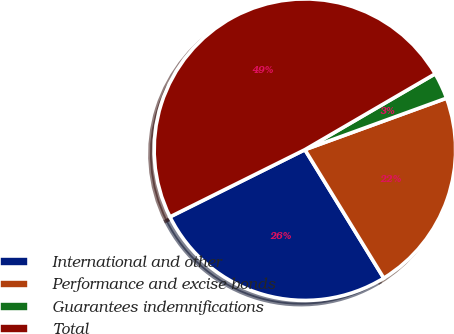<chart> <loc_0><loc_0><loc_500><loc_500><pie_chart><fcel>International and other<fcel>Performance and excise bonds<fcel>Guarantees indemnifications<fcel>Total<nl><fcel>26.41%<fcel>21.79%<fcel>2.84%<fcel>48.96%<nl></chart> 